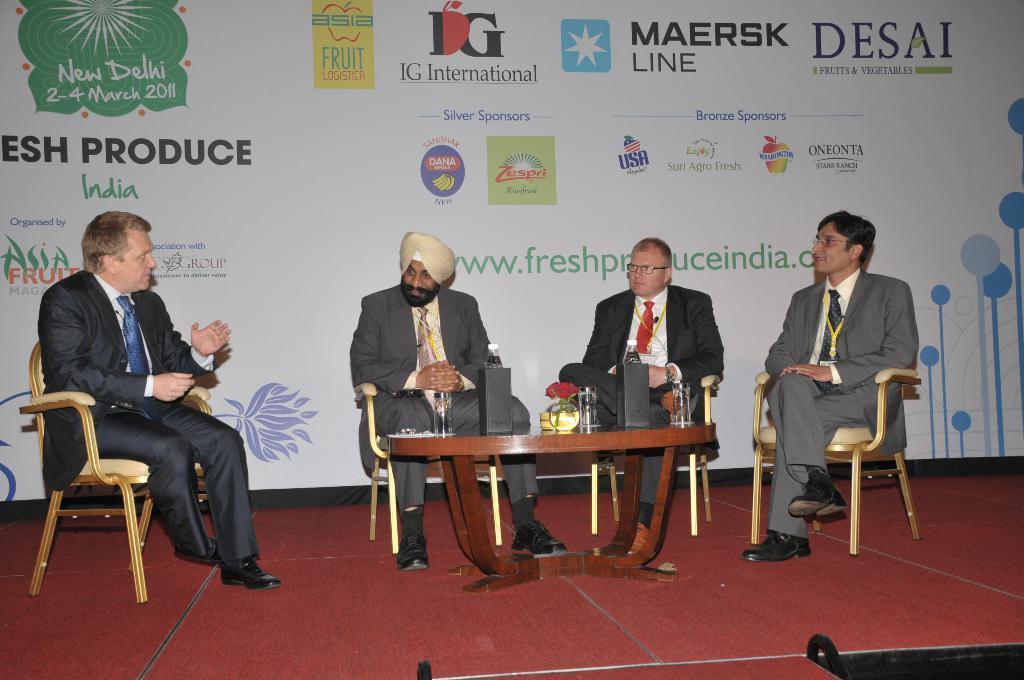Describe this image in one or two sentences. In the image we can see there is a four men who are sitting on chairs and in front of there is a table on which there are two speakers kept and behind them there is a banner. 